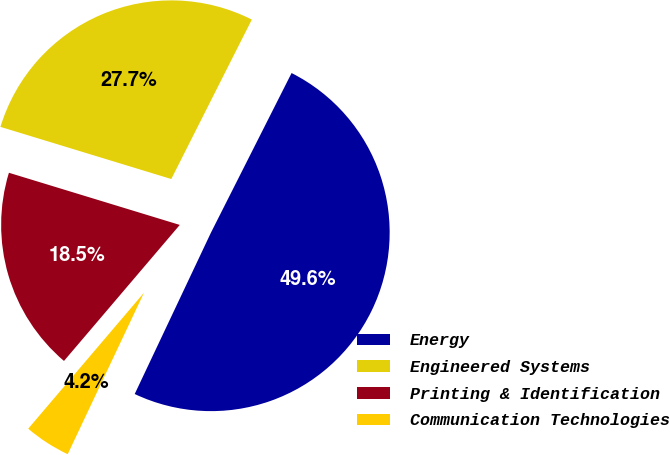Convert chart. <chart><loc_0><loc_0><loc_500><loc_500><pie_chart><fcel>Energy<fcel>Engineered Systems<fcel>Printing & Identification<fcel>Communication Technologies<nl><fcel>49.58%<fcel>27.73%<fcel>18.49%<fcel>4.2%<nl></chart> 